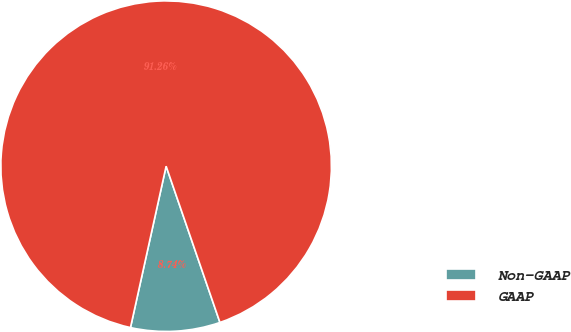Convert chart to OTSL. <chart><loc_0><loc_0><loc_500><loc_500><pie_chart><fcel>Non-GAAP<fcel>GAAP<nl><fcel>8.74%<fcel>91.26%<nl></chart> 